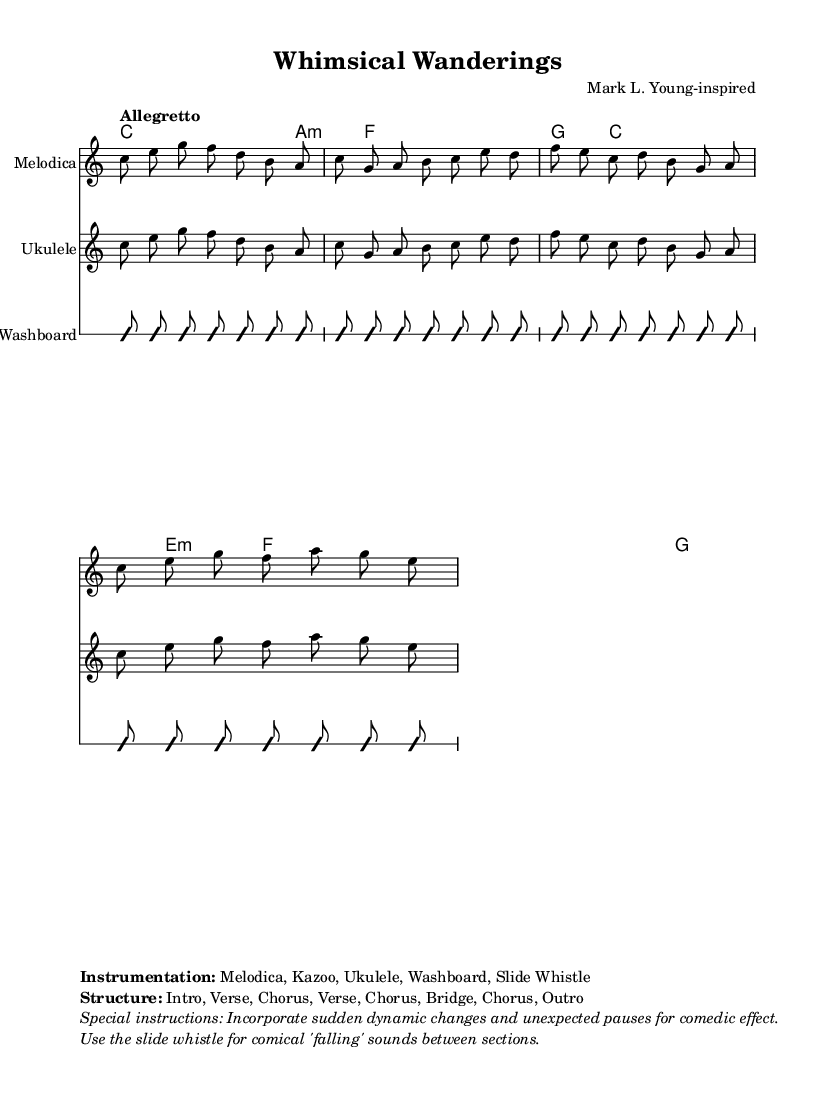What is the key signature of this music? The key signature is C major, which has no sharps or flats.
Answer: C major What is the time signature of this music? The time signature is indicated at the beginning of the score, shown as 7/8, meaning there are seven beats in a measure, with the eighth note getting the beat.
Answer: 7/8 What is the tempo marking for this piece? The tempo marking is found at the beginning and tells us to play it at an "Allegretto" pace, which is moderately fast.
Answer: Allegretto How many sections are in the structure of the piece? By examining the structure outlined in the score, we see it includes an Intro, two Verses, three Choruses, a Bridge, and an Outro, totaling eight sections.
Answer: Eight What unusual instrument is featured in this score? Looking at the instrumentation specified in the score's markup, one unusual instrument listed is the "Washboard," which is not commonly used in traditional music settings.
Answer: Washboard What is the purpose of the slide whistle in this music? The score includes special instructions indicating that the slide whistle should be used for comical "falling" sounds between sections, enhancing the quirky nature of the composition.
Answer: Comical "falling" sounds Which section follows the Chorus in the structure? Upon reviewing the structure, the Bridge immediately follows the last Chorus, as outlined in the provided section order.
Answer: Bridge 